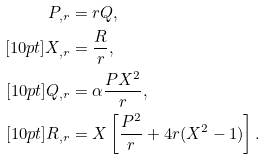<formula> <loc_0><loc_0><loc_500><loc_500>P _ { , r } & = r Q , \\ [ 1 0 p t ] X _ { , r } & = \frac { R } { r } , \\ [ 1 0 p t ] Q _ { , r } & = \alpha \frac { P X ^ { 2 } } { r } , \\ [ 1 0 p t ] R _ { , r } & = X \left [ \frac { P ^ { 2 } } { r } + 4 r ( X ^ { 2 } - 1 ) \right ] .</formula> 